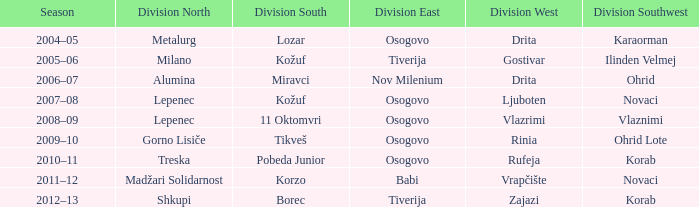Who won Division North when Division Southwest was won by Novaci and Division West by Vrapčište? Madžari Solidarnost. 